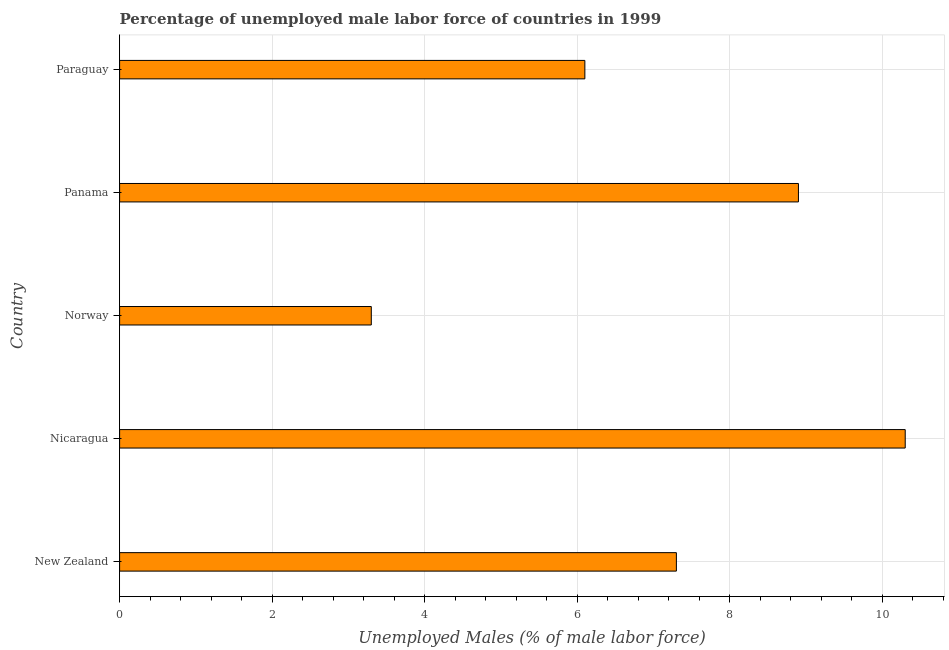Does the graph contain any zero values?
Your answer should be very brief. No. Does the graph contain grids?
Offer a very short reply. Yes. What is the title of the graph?
Your response must be concise. Percentage of unemployed male labor force of countries in 1999. What is the label or title of the X-axis?
Make the answer very short. Unemployed Males (% of male labor force). What is the total unemployed male labour force in Norway?
Offer a very short reply. 3.3. Across all countries, what is the maximum total unemployed male labour force?
Offer a very short reply. 10.3. Across all countries, what is the minimum total unemployed male labour force?
Your response must be concise. 3.3. In which country was the total unemployed male labour force maximum?
Keep it short and to the point. Nicaragua. What is the sum of the total unemployed male labour force?
Make the answer very short. 35.9. What is the difference between the total unemployed male labour force in Nicaragua and Norway?
Make the answer very short. 7. What is the average total unemployed male labour force per country?
Make the answer very short. 7.18. What is the median total unemployed male labour force?
Provide a short and direct response. 7.3. In how many countries, is the total unemployed male labour force greater than 2.8 %?
Offer a terse response. 5. What is the ratio of the total unemployed male labour force in New Zealand to that in Panama?
Provide a short and direct response. 0.82. Is the total unemployed male labour force in Nicaragua less than that in Panama?
Offer a terse response. No. Is the difference between the total unemployed male labour force in New Zealand and Norway greater than the difference between any two countries?
Offer a terse response. No. Is the sum of the total unemployed male labour force in Nicaragua and Paraguay greater than the maximum total unemployed male labour force across all countries?
Offer a terse response. Yes. What is the difference between the highest and the lowest total unemployed male labour force?
Your answer should be very brief. 7. What is the difference between two consecutive major ticks on the X-axis?
Provide a succinct answer. 2. Are the values on the major ticks of X-axis written in scientific E-notation?
Provide a succinct answer. No. What is the Unemployed Males (% of male labor force) of New Zealand?
Offer a terse response. 7.3. What is the Unemployed Males (% of male labor force) of Nicaragua?
Make the answer very short. 10.3. What is the Unemployed Males (% of male labor force) in Norway?
Give a very brief answer. 3.3. What is the Unemployed Males (% of male labor force) in Panama?
Offer a terse response. 8.9. What is the Unemployed Males (% of male labor force) in Paraguay?
Provide a succinct answer. 6.1. What is the difference between the Unemployed Males (% of male labor force) in New Zealand and Paraguay?
Make the answer very short. 1.2. What is the difference between the Unemployed Males (% of male labor force) in Nicaragua and Panama?
Provide a succinct answer. 1.4. What is the difference between the Unemployed Males (% of male labor force) in Nicaragua and Paraguay?
Make the answer very short. 4.2. What is the difference between the Unemployed Males (% of male labor force) in Norway and Panama?
Ensure brevity in your answer.  -5.6. What is the difference between the Unemployed Males (% of male labor force) in Norway and Paraguay?
Make the answer very short. -2.8. What is the difference between the Unemployed Males (% of male labor force) in Panama and Paraguay?
Keep it short and to the point. 2.8. What is the ratio of the Unemployed Males (% of male labor force) in New Zealand to that in Nicaragua?
Give a very brief answer. 0.71. What is the ratio of the Unemployed Males (% of male labor force) in New Zealand to that in Norway?
Your answer should be compact. 2.21. What is the ratio of the Unemployed Males (% of male labor force) in New Zealand to that in Panama?
Keep it short and to the point. 0.82. What is the ratio of the Unemployed Males (% of male labor force) in New Zealand to that in Paraguay?
Provide a succinct answer. 1.2. What is the ratio of the Unemployed Males (% of male labor force) in Nicaragua to that in Norway?
Keep it short and to the point. 3.12. What is the ratio of the Unemployed Males (% of male labor force) in Nicaragua to that in Panama?
Offer a very short reply. 1.16. What is the ratio of the Unemployed Males (% of male labor force) in Nicaragua to that in Paraguay?
Provide a short and direct response. 1.69. What is the ratio of the Unemployed Males (% of male labor force) in Norway to that in Panama?
Your answer should be compact. 0.37. What is the ratio of the Unemployed Males (% of male labor force) in Norway to that in Paraguay?
Give a very brief answer. 0.54. What is the ratio of the Unemployed Males (% of male labor force) in Panama to that in Paraguay?
Make the answer very short. 1.46. 